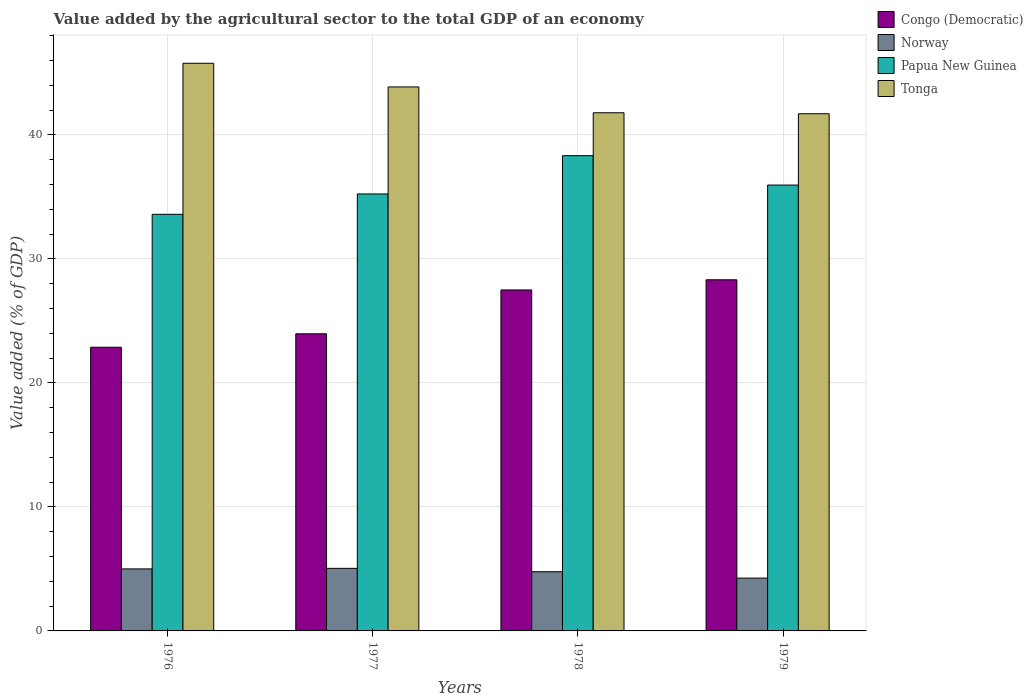How many groups of bars are there?
Provide a short and direct response. 4. How many bars are there on the 1st tick from the right?
Offer a terse response. 4. What is the label of the 3rd group of bars from the left?
Your answer should be very brief. 1978. In how many cases, is the number of bars for a given year not equal to the number of legend labels?
Provide a succinct answer. 0. What is the value added by the agricultural sector to the total GDP in Papua New Guinea in 1979?
Your response must be concise. 35.96. Across all years, what is the maximum value added by the agricultural sector to the total GDP in Congo (Democratic)?
Keep it short and to the point. 28.32. Across all years, what is the minimum value added by the agricultural sector to the total GDP in Congo (Democratic)?
Your response must be concise. 22.88. In which year was the value added by the agricultural sector to the total GDP in Papua New Guinea maximum?
Offer a terse response. 1978. In which year was the value added by the agricultural sector to the total GDP in Tonga minimum?
Ensure brevity in your answer.  1979. What is the total value added by the agricultural sector to the total GDP in Norway in the graph?
Keep it short and to the point. 19.08. What is the difference between the value added by the agricultural sector to the total GDP in Norway in 1977 and that in 1978?
Give a very brief answer. 0.27. What is the difference between the value added by the agricultural sector to the total GDP in Congo (Democratic) in 1976 and the value added by the agricultural sector to the total GDP in Papua New Guinea in 1978?
Make the answer very short. -15.45. What is the average value added by the agricultural sector to the total GDP in Papua New Guinea per year?
Offer a terse response. 35.78. In the year 1978, what is the difference between the value added by the agricultural sector to the total GDP in Papua New Guinea and value added by the agricultural sector to the total GDP in Tonga?
Offer a very short reply. -3.46. What is the ratio of the value added by the agricultural sector to the total GDP in Congo (Democratic) in 1977 to that in 1979?
Provide a short and direct response. 0.85. Is the difference between the value added by the agricultural sector to the total GDP in Papua New Guinea in 1976 and 1978 greater than the difference between the value added by the agricultural sector to the total GDP in Tonga in 1976 and 1978?
Provide a short and direct response. No. What is the difference between the highest and the second highest value added by the agricultural sector to the total GDP in Papua New Guinea?
Offer a very short reply. 2.37. What is the difference between the highest and the lowest value added by the agricultural sector to the total GDP in Papua New Guinea?
Give a very brief answer. 4.73. What does the 1st bar from the left in 1978 represents?
Provide a short and direct response. Congo (Democratic). What does the 2nd bar from the right in 1976 represents?
Offer a very short reply. Papua New Guinea. Are all the bars in the graph horizontal?
Keep it short and to the point. No. How many years are there in the graph?
Make the answer very short. 4. What is the difference between two consecutive major ticks on the Y-axis?
Give a very brief answer. 10. Does the graph contain any zero values?
Your response must be concise. No. How are the legend labels stacked?
Your answer should be compact. Vertical. What is the title of the graph?
Provide a short and direct response. Value added by the agricultural sector to the total GDP of an economy. What is the label or title of the Y-axis?
Your answer should be compact. Value added (% of GDP). What is the Value added (% of GDP) of Congo (Democratic) in 1976?
Make the answer very short. 22.88. What is the Value added (% of GDP) in Norway in 1976?
Your answer should be very brief. 5. What is the Value added (% of GDP) of Papua New Guinea in 1976?
Keep it short and to the point. 33.6. What is the Value added (% of GDP) of Tonga in 1976?
Keep it short and to the point. 45.78. What is the Value added (% of GDP) in Congo (Democratic) in 1977?
Ensure brevity in your answer.  23.96. What is the Value added (% of GDP) of Norway in 1977?
Your answer should be compact. 5.05. What is the Value added (% of GDP) of Papua New Guinea in 1977?
Provide a short and direct response. 35.24. What is the Value added (% of GDP) in Tonga in 1977?
Your response must be concise. 43.87. What is the Value added (% of GDP) of Congo (Democratic) in 1978?
Make the answer very short. 27.5. What is the Value added (% of GDP) of Norway in 1978?
Provide a succinct answer. 4.77. What is the Value added (% of GDP) in Papua New Guinea in 1978?
Keep it short and to the point. 38.33. What is the Value added (% of GDP) in Tonga in 1978?
Offer a terse response. 41.79. What is the Value added (% of GDP) in Congo (Democratic) in 1979?
Make the answer very short. 28.32. What is the Value added (% of GDP) of Norway in 1979?
Ensure brevity in your answer.  4.26. What is the Value added (% of GDP) of Papua New Guinea in 1979?
Provide a short and direct response. 35.96. What is the Value added (% of GDP) in Tonga in 1979?
Make the answer very short. 41.71. Across all years, what is the maximum Value added (% of GDP) of Congo (Democratic)?
Give a very brief answer. 28.32. Across all years, what is the maximum Value added (% of GDP) of Norway?
Your response must be concise. 5.05. Across all years, what is the maximum Value added (% of GDP) in Papua New Guinea?
Ensure brevity in your answer.  38.33. Across all years, what is the maximum Value added (% of GDP) in Tonga?
Your answer should be very brief. 45.78. Across all years, what is the minimum Value added (% of GDP) in Congo (Democratic)?
Offer a terse response. 22.88. Across all years, what is the minimum Value added (% of GDP) in Norway?
Offer a terse response. 4.26. Across all years, what is the minimum Value added (% of GDP) in Papua New Guinea?
Ensure brevity in your answer.  33.6. Across all years, what is the minimum Value added (% of GDP) in Tonga?
Give a very brief answer. 41.71. What is the total Value added (% of GDP) in Congo (Democratic) in the graph?
Your response must be concise. 102.66. What is the total Value added (% of GDP) of Norway in the graph?
Offer a very short reply. 19.08. What is the total Value added (% of GDP) of Papua New Guinea in the graph?
Give a very brief answer. 143.13. What is the total Value added (% of GDP) in Tonga in the graph?
Your answer should be very brief. 173.16. What is the difference between the Value added (% of GDP) in Congo (Democratic) in 1976 and that in 1977?
Your answer should be compact. -1.09. What is the difference between the Value added (% of GDP) of Norway in 1976 and that in 1977?
Provide a succinct answer. -0.04. What is the difference between the Value added (% of GDP) of Papua New Guinea in 1976 and that in 1977?
Provide a short and direct response. -1.64. What is the difference between the Value added (% of GDP) of Tonga in 1976 and that in 1977?
Offer a very short reply. 1.91. What is the difference between the Value added (% of GDP) in Congo (Democratic) in 1976 and that in 1978?
Ensure brevity in your answer.  -4.62. What is the difference between the Value added (% of GDP) in Norway in 1976 and that in 1978?
Offer a very short reply. 0.23. What is the difference between the Value added (% of GDP) of Papua New Guinea in 1976 and that in 1978?
Make the answer very short. -4.73. What is the difference between the Value added (% of GDP) of Tonga in 1976 and that in 1978?
Make the answer very short. 3.99. What is the difference between the Value added (% of GDP) of Congo (Democratic) in 1976 and that in 1979?
Ensure brevity in your answer.  -5.44. What is the difference between the Value added (% of GDP) of Norway in 1976 and that in 1979?
Offer a terse response. 0.74. What is the difference between the Value added (% of GDP) of Papua New Guinea in 1976 and that in 1979?
Make the answer very short. -2.36. What is the difference between the Value added (% of GDP) of Tonga in 1976 and that in 1979?
Give a very brief answer. 4.07. What is the difference between the Value added (% of GDP) in Congo (Democratic) in 1977 and that in 1978?
Give a very brief answer. -3.53. What is the difference between the Value added (% of GDP) of Norway in 1977 and that in 1978?
Your answer should be compact. 0.27. What is the difference between the Value added (% of GDP) of Papua New Guinea in 1977 and that in 1978?
Ensure brevity in your answer.  -3.09. What is the difference between the Value added (% of GDP) of Tonga in 1977 and that in 1978?
Provide a short and direct response. 2.08. What is the difference between the Value added (% of GDP) of Congo (Democratic) in 1977 and that in 1979?
Offer a terse response. -4.35. What is the difference between the Value added (% of GDP) of Norway in 1977 and that in 1979?
Ensure brevity in your answer.  0.79. What is the difference between the Value added (% of GDP) of Papua New Guinea in 1977 and that in 1979?
Ensure brevity in your answer.  -0.72. What is the difference between the Value added (% of GDP) in Tonga in 1977 and that in 1979?
Provide a short and direct response. 2.16. What is the difference between the Value added (% of GDP) of Congo (Democratic) in 1978 and that in 1979?
Offer a very short reply. -0.82. What is the difference between the Value added (% of GDP) in Norway in 1978 and that in 1979?
Give a very brief answer. 0.51. What is the difference between the Value added (% of GDP) of Papua New Guinea in 1978 and that in 1979?
Offer a terse response. 2.37. What is the difference between the Value added (% of GDP) of Tonga in 1978 and that in 1979?
Ensure brevity in your answer.  0.08. What is the difference between the Value added (% of GDP) of Congo (Democratic) in 1976 and the Value added (% of GDP) of Norway in 1977?
Offer a terse response. 17.83. What is the difference between the Value added (% of GDP) of Congo (Democratic) in 1976 and the Value added (% of GDP) of Papua New Guinea in 1977?
Offer a very short reply. -12.36. What is the difference between the Value added (% of GDP) in Congo (Democratic) in 1976 and the Value added (% of GDP) in Tonga in 1977?
Give a very brief answer. -20.99. What is the difference between the Value added (% of GDP) of Norway in 1976 and the Value added (% of GDP) of Papua New Guinea in 1977?
Make the answer very short. -30.24. What is the difference between the Value added (% of GDP) in Norway in 1976 and the Value added (% of GDP) in Tonga in 1977?
Give a very brief answer. -38.87. What is the difference between the Value added (% of GDP) in Papua New Guinea in 1976 and the Value added (% of GDP) in Tonga in 1977?
Your response must be concise. -10.27. What is the difference between the Value added (% of GDP) of Congo (Democratic) in 1976 and the Value added (% of GDP) of Norway in 1978?
Make the answer very short. 18.1. What is the difference between the Value added (% of GDP) in Congo (Democratic) in 1976 and the Value added (% of GDP) in Papua New Guinea in 1978?
Provide a short and direct response. -15.45. What is the difference between the Value added (% of GDP) in Congo (Democratic) in 1976 and the Value added (% of GDP) in Tonga in 1978?
Offer a very short reply. -18.91. What is the difference between the Value added (% of GDP) of Norway in 1976 and the Value added (% of GDP) of Papua New Guinea in 1978?
Give a very brief answer. -33.33. What is the difference between the Value added (% of GDP) in Norway in 1976 and the Value added (% of GDP) in Tonga in 1978?
Ensure brevity in your answer.  -36.79. What is the difference between the Value added (% of GDP) in Papua New Guinea in 1976 and the Value added (% of GDP) in Tonga in 1978?
Your answer should be very brief. -8.19. What is the difference between the Value added (% of GDP) in Congo (Democratic) in 1976 and the Value added (% of GDP) in Norway in 1979?
Your answer should be very brief. 18.62. What is the difference between the Value added (% of GDP) in Congo (Democratic) in 1976 and the Value added (% of GDP) in Papua New Guinea in 1979?
Offer a terse response. -13.08. What is the difference between the Value added (% of GDP) of Congo (Democratic) in 1976 and the Value added (% of GDP) of Tonga in 1979?
Offer a terse response. -18.83. What is the difference between the Value added (% of GDP) in Norway in 1976 and the Value added (% of GDP) in Papua New Guinea in 1979?
Provide a succinct answer. -30.96. What is the difference between the Value added (% of GDP) of Norway in 1976 and the Value added (% of GDP) of Tonga in 1979?
Give a very brief answer. -36.71. What is the difference between the Value added (% of GDP) of Papua New Guinea in 1976 and the Value added (% of GDP) of Tonga in 1979?
Your answer should be very brief. -8.11. What is the difference between the Value added (% of GDP) of Congo (Democratic) in 1977 and the Value added (% of GDP) of Norway in 1978?
Ensure brevity in your answer.  19.19. What is the difference between the Value added (% of GDP) of Congo (Democratic) in 1977 and the Value added (% of GDP) of Papua New Guinea in 1978?
Offer a terse response. -14.36. What is the difference between the Value added (% of GDP) in Congo (Democratic) in 1977 and the Value added (% of GDP) in Tonga in 1978?
Offer a very short reply. -17.83. What is the difference between the Value added (% of GDP) of Norway in 1977 and the Value added (% of GDP) of Papua New Guinea in 1978?
Provide a succinct answer. -33.28. What is the difference between the Value added (% of GDP) of Norway in 1977 and the Value added (% of GDP) of Tonga in 1978?
Ensure brevity in your answer.  -36.74. What is the difference between the Value added (% of GDP) in Papua New Guinea in 1977 and the Value added (% of GDP) in Tonga in 1978?
Your answer should be very brief. -6.55. What is the difference between the Value added (% of GDP) of Congo (Democratic) in 1977 and the Value added (% of GDP) of Norway in 1979?
Offer a very short reply. 19.7. What is the difference between the Value added (% of GDP) in Congo (Democratic) in 1977 and the Value added (% of GDP) in Papua New Guinea in 1979?
Keep it short and to the point. -11.99. What is the difference between the Value added (% of GDP) in Congo (Democratic) in 1977 and the Value added (% of GDP) in Tonga in 1979?
Make the answer very short. -17.75. What is the difference between the Value added (% of GDP) in Norway in 1977 and the Value added (% of GDP) in Papua New Guinea in 1979?
Ensure brevity in your answer.  -30.91. What is the difference between the Value added (% of GDP) of Norway in 1977 and the Value added (% of GDP) of Tonga in 1979?
Your response must be concise. -36.66. What is the difference between the Value added (% of GDP) in Papua New Guinea in 1977 and the Value added (% of GDP) in Tonga in 1979?
Provide a short and direct response. -6.47. What is the difference between the Value added (% of GDP) of Congo (Democratic) in 1978 and the Value added (% of GDP) of Norway in 1979?
Give a very brief answer. 23.24. What is the difference between the Value added (% of GDP) in Congo (Democratic) in 1978 and the Value added (% of GDP) in Papua New Guinea in 1979?
Offer a terse response. -8.46. What is the difference between the Value added (% of GDP) of Congo (Democratic) in 1978 and the Value added (% of GDP) of Tonga in 1979?
Your answer should be compact. -14.21. What is the difference between the Value added (% of GDP) in Norway in 1978 and the Value added (% of GDP) in Papua New Guinea in 1979?
Your response must be concise. -31.18. What is the difference between the Value added (% of GDP) in Norway in 1978 and the Value added (% of GDP) in Tonga in 1979?
Offer a terse response. -36.94. What is the difference between the Value added (% of GDP) in Papua New Guinea in 1978 and the Value added (% of GDP) in Tonga in 1979?
Your response must be concise. -3.38. What is the average Value added (% of GDP) of Congo (Democratic) per year?
Your response must be concise. 25.66. What is the average Value added (% of GDP) in Norway per year?
Your answer should be compact. 4.77. What is the average Value added (% of GDP) in Papua New Guinea per year?
Your answer should be compact. 35.78. What is the average Value added (% of GDP) in Tonga per year?
Provide a short and direct response. 43.29. In the year 1976, what is the difference between the Value added (% of GDP) of Congo (Democratic) and Value added (% of GDP) of Norway?
Provide a succinct answer. 17.88. In the year 1976, what is the difference between the Value added (% of GDP) in Congo (Democratic) and Value added (% of GDP) in Papua New Guinea?
Your answer should be very brief. -10.72. In the year 1976, what is the difference between the Value added (% of GDP) in Congo (Democratic) and Value added (% of GDP) in Tonga?
Give a very brief answer. -22.9. In the year 1976, what is the difference between the Value added (% of GDP) in Norway and Value added (% of GDP) in Papua New Guinea?
Keep it short and to the point. -28.6. In the year 1976, what is the difference between the Value added (% of GDP) in Norway and Value added (% of GDP) in Tonga?
Give a very brief answer. -40.78. In the year 1976, what is the difference between the Value added (% of GDP) of Papua New Guinea and Value added (% of GDP) of Tonga?
Give a very brief answer. -12.18. In the year 1977, what is the difference between the Value added (% of GDP) of Congo (Democratic) and Value added (% of GDP) of Norway?
Provide a short and direct response. 18.92. In the year 1977, what is the difference between the Value added (% of GDP) of Congo (Democratic) and Value added (% of GDP) of Papua New Guinea?
Your answer should be compact. -11.28. In the year 1977, what is the difference between the Value added (% of GDP) in Congo (Democratic) and Value added (% of GDP) in Tonga?
Provide a short and direct response. -19.91. In the year 1977, what is the difference between the Value added (% of GDP) in Norway and Value added (% of GDP) in Papua New Guinea?
Offer a very short reply. -30.2. In the year 1977, what is the difference between the Value added (% of GDP) in Norway and Value added (% of GDP) in Tonga?
Your answer should be compact. -38.83. In the year 1977, what is the difference between the Value added (% of GDP) in Papua New Guinea and Value added (% of GDP) in Tonga?
Ensure brevity in your answer.  -8.63. In the year 1978, what is the difference between the Value added (% of GDP) in Congo (Democratic) and Value added (% of GDP) in Norway?
Provide a short and direct response. 22.72. In the year 1978, what is the difference between the Value added (% of GDP) in Congo (Democratic) and Value added (% of GDP) in Papua New Guinea?
Offer a terse response. -10.83. In the year 1978, what is the difference between the Value added (% of GDP) in Congo (Democratic) and Value added (% of GDP) in Tonga?
Provide a succinct answer. -14.29. In the year 1978, what is the difference between the Value added (% of GDP) in Norway and Value added (% of GDP) in Papua New Guinea?
Your answer should be very brief. -33.55. In the year 1978, what is the difference between the Value added (% of GDP) in Norway and Value added (% of GDP) in Tonga?
Make the answer very short. -37.02. In the year 1978, what is the difference between the Value added (% of GDP) of Papua New Guinea and Value added (% of GDP) of Tonga?
Your answer should be very brief. -3.46. In the year 1979, what is the difference between the Value added (% of GDP) of Congo (Democratic) and Value added (% of GDP) of Norway?
Make the answer very short. 24.06. In the year 1979, what is the difference between the Value added (% of GDP) in Congo (Democratic) and Value added (% of GDP) in Papua New Guinea?
Provide a succinct answer. -7.64. In the year 1979, what is the difference between the Value added (% of GDP) of Congo (Democratic) and Value added (% of GDP) of Tonga?
Your response must be concise. -13.39. In the year 1979, what is the difference between the Value added (% of GDP) in Norway and Value added (% of GDP) in Papua New Guinea?
Give a very brief answer. -31.7. In the year 1979, what is the difference between the Value added (% of GDP) in Norway and Value added (% of GDP) in Tonga?
Your answer should be very brief. -37.45. In the year 1979, what is the difference between the Value added (% of GDP) in Papua New Guinea and Value added (% of GDP) in Tonga?
Give a very brief answer. -5.75. What is the ratio of the Value added (% of GDP) in Congo (Democratic) in 1976 to that in 1977?
Give a very brief answer. 0.95. What is the ratio of the Value added (% of GDP) of Papua New Guinea in 1976 to that in 1977?
Give a very brief answer. 0.95. What is the ratio of the Value added (% of GDP) in Tonga in 1976 to that in 1977?
Keep it short and to the point. 1.04. What is the ratio of the Value added (% of GDP) in Congo (Democratic) in 1976 to that in 1978?
Your response must be concise. 0.83. What is the ratio of the Value added (% of GDP) of Norway in 1976 to that in 1978?
Your answer should be compact. 1.05. What is the ratio of the Value added (% of GDP) of Papua New Guinea in 1976 to that in 1978?
Ensure brevity in your answer.  0.88. What is the ratio of the Value added (% of GDP) in Tonga in 1976 to that in 1978?
Ensure brevity in your answer.  1.1. What is the ratio of the Value added (% of GDP) of Congo (Democratic) in 1976 to that in 1979?
Your answer should be very brief. 0.81. What is the ratio of the Value added (% of GDP) of Norway in 1976 to that in 1979?
Offer a very short reply. 1.17. What is the ratio of the Value added (% of GDP) of Papua New Guinea in 1976 to that in 1979?
Give a very brief answer. 0.93. What is the ratio of the Value added (% of GDP) of Tonga in 1976 to that in 1979?
Provide a short and direct response. 1.1. What is the ratio of the Value added (% of GDP) of Congo (Democratic) in 1977 to that in 1978?
Your answer should be very brief. 0.87. What is the ratio of the Value added (% of GDP) of Norway in 1977 to that in 1978?
Your answer should be very brief. 1.06. What is the ratio of the Value added (% of GDP) in Papua New Guinea in 1977 to that in 1978?
Make the answer very short. 0.92. What is the ratio of the Value added (% of GDP) in Tonga in 1977 to that in 1978?
Ensure brevity in your answer.  1.05. What is the ratio of the Value added (% of GDP) in Congo (Democratic) in 1977 to that in 1979?
Your response must be concise. 0.85. What is the ratio of the Value added (% of GDP) of Norway in 1977 to that in 1979?
Provide a short and direct response. 1.18. What is the ratio of the Value added (% of GDP) of Papua New Guinea in 1977 to that in 1979?
Offer a very short reply. 0.98. What is the ratio of the Value added (% of GDP) of Tonga in 1977 to that in 1979?
Provide a succinct answer. 1.05. What is the ratio of the Value added (% of GDP) in Norway in 1978 to that in 1979?
Your answer should be very brief. 1.12. What is the ratio of the Value added (% of GDP) of Papua New Guinea in 1978 to that in 1979?
Make the answer very short. 1.07. What is the difference between the highest and the second highest Value added (% of GDP) of Congo (Democratic)?
Keep it short and to the point. 0.82. What is the difference between the highest and the second highest Value added (% of GDP) of Norway?
Offer a very short reply. 0.04. What is the difference between the highest and the second highest Value added (% of GDP) of Papua New Guinea?
Offer a very short reply. 2.37. What is the difference between the highest and the second highest Value added (% of GDP) of Tonga?
Your response must be concise. 1.91. What is the difference between the highest and the lowest Value added (% of GDP) of Congo (Democratic)?
Ensure brevity in your answer.  5.44. What is the difference between the highest and the lowest Value added (% of GDP) of Norway?
Your response must be concise. 0.79. What is the difference between the highest and the lowest Value added (% of GDP) in Papua New Guinea?
Your answer should be very brief. 4.73. What is the difference between the highest and the lowest Value added (% of GDP) in Tonga?
Ensure brevity in your answer.  4.07. 